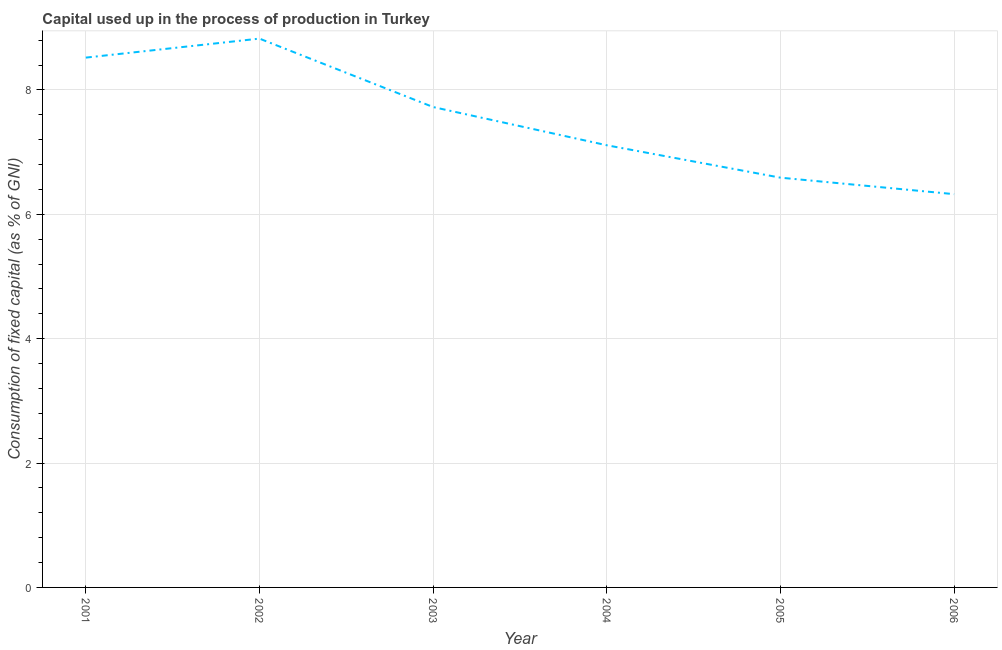What is the consumption of fixed capital in 2005?
Offer a very short reply. 6.59. Across all years, what is the maximum consumption of fixed capital?
Your response must be concise. 8.82. Across all years, what is the minimum consumption of fixed capital?
Give a very brief answer. 6.32. In which year was the consumption of fixed capital maximum?
Give a very brief answer. 2002. What is the sum of the consumption of fixed capital?
Make the answer very short. 45.09. What is the difference between the consumption of fixed capital in 2003 and 2006?
Offer a terse response. 1.4. What is the average consumption of fixed capital per year?
Offer a very short reply. 7.51. What is the median consumption of fixed capital?
Ensure brevity in your answer.  7.42. In how many years, is the consumption of fixed capital greater than 6.8 %?
Give a very brief answer. 4. What is the ratio of the consumption of fixed capital in 2002 to that in 2005?
Offer a very short reply. 1.34. Is the consumption of fixed capital in 2002 less than that in 2003?
Provide a short and direct response. No. What is the difference between the highest and the second highest consumption of fixed capital?
Offer a very short reply. 0.31. What is the difference between the highest and the lowest consumption of fixed capital?
Give a very brief answer. 2.5. How many lines are there?
Make the answer very short. 1. What is the difference between two consecutive major ticks on the Y-axis?
Provide a succinct answer. 2. Does the graph contain any zero values?
Your response must be concise. No. Does the graph contain grids?
Provide a short and direct response. Yes. What is the title of the graph?
Give a very brief answer. Capital used up in the process of production in Turkey. What is the label or title of the X-axis?
Offer a terse response. Year. What is the label or title of the Y-axis?
Provide a short and direct response. Consumption of fixed capital (as % of GNI). What is the Consumption of fixed capital (as % of GNI) of 2001?
Your answer should be compact. 8.52. What is the Consumption of fixed capital (as % of GNI) of 2002?
Ensure brevity in your answer.  8.82. What is the Consumption of fixed capital (as % of GNI) in 2003?
Make the answer very short. 7.72. What is the Consumption of fixed capital (as % of GNI) of 2004?
Provide a short and direct response. 7.11. What is the Consumption of fixed capital (as % of GNI) in 2005?
Your answer should be compact. 6.59. What is the Consumption of fixed capital (as % of GNI) of 2006?
Offer a terse response. 6.32. What is the difference between the Consumption of fixed capital (as % of GNI) in 2001 and 2002?
Your response must be concise. -0.31. What is the difference between the Consumption of fixed capital (as % of GNI) in 2001 and 2003?
Provide a short and direct response. 0.79. What is the difference between the Consumption of fixed capital (as % of GNI) in 2001 and 2004?
Your answer should be compact. 1.41. What is the difference between the Consumption of fixed capital (as % of GNI) in 2001 and 2005?
Provide a succinct answer. 1.93. What is the difference between the Consumption of fixed capital (as % of GNI) in 2001 and 2006?
Give a very brief answer. 2.2. What is the difference between the Consumption of fixed capital (as % of GNI) in 2002 and 2003?
Offer a terse response. 1.1. What is the difference between the Consumption of fixed capital (as % of GNI) in 2002 and 2004?
Offer a terse response. 1.71. What is the difference between the Consumption of fixed capital (as % of GNI) in 2002 and 2005?
Ensure brevity in your answer.  2.24. What is the difference between the Consumption of fixed capital (as % of GNI) in 2002 and 2006?
Offer a terse response. 2.5. What is the difference between the Consumption of fixed capital (as % of GNI) in 2003 and 2004?
Give a very brief answer. 0.61. What is the difference between the Consumption of fixed capital (as % of GNI) in 2003 and 2005?
Your response must be concise. 1.14. What is the difference between the Consumption of fixed capital (as % of GNI) in 2003 and 2006?
Your answer should be very brief. 1.4. What is the difference between the Consumption of fixed capital (as % of GNI) in 2004 and 2005?
Your answer should be very brief. 0.52. What is the difference between the Consumption of fixed capital (as % of GNI) in 2004 and 2006?
Give a very brief answer. 0.79. What is the difference between the Consumption of fixed capital (as % of GNI) in 2005 and 2006?
Offer a terse response. 0.27. What is the ratio of the Consumption of fixed capital (as % of GNI) in 2001 to that in 2003?
Provide a short and direct response. 1.1. What is the ratio of the Consumption of fixed capital (as % of GNI) in 2001 to that in 2004?
Your response must be concise. 1.2. What is the ratio of the Consumption of fixed capital (as % of GNI) in 2001 to that in 2005?
Your answer should be compact. 1.29. What is the ratio of the Consumption of fixed capital (as % of GNI) in 2001 to that in 2006?
Provide a succinct answer. 1.35. What is the ratio of the Consumption of fixed capital (as % of GNI) in 2002 to that in 2003?
Give a very brief answer. 1.14. What is the ratio of the Consumption of fixed capital (as % of GNI) in 2002 to that in 2004?
Offer a terse response. 1.24. What is the ratio of the Consumption of fixed capital (as % of GNI) in 2002 to that in 2005?
Offer a very short reply. 1.34. What is the ratio of the Consumption of fixed capital (as % of GNI) in 2002 to that in 2006?
Ensure brevity in your answer.  1.4. What is the ratio of the Consumption of fixed capital (as % of GNI) in 2003 to that in 2004?
Offer a very short reply. 1.09. What is the ratio of the Consumption of fixed capital (as % of GNI) in 2003 to that in 2005?
Keep it short and to the point. 1.17. What is the ratio of the Consumption of fixed capital (as % of GNI) in 2003 to that in 2006?
Your answer should be compact. 1.22. What is the ratio of the Consumption of fixed capital (as % of GNI) in 2004 to that in 2005?
Your response must be concise. 1.08. What is the ratio of the Consumption of fixed capital (as % of GNI) in 2004 to that in 2006?
Ensure brevity in your answer.  1.12. What is the ratio of the Consumption of fixed capital (as % of GNI) in 2005 to that in 2006?
Your answer should be very brief. 1.04. 